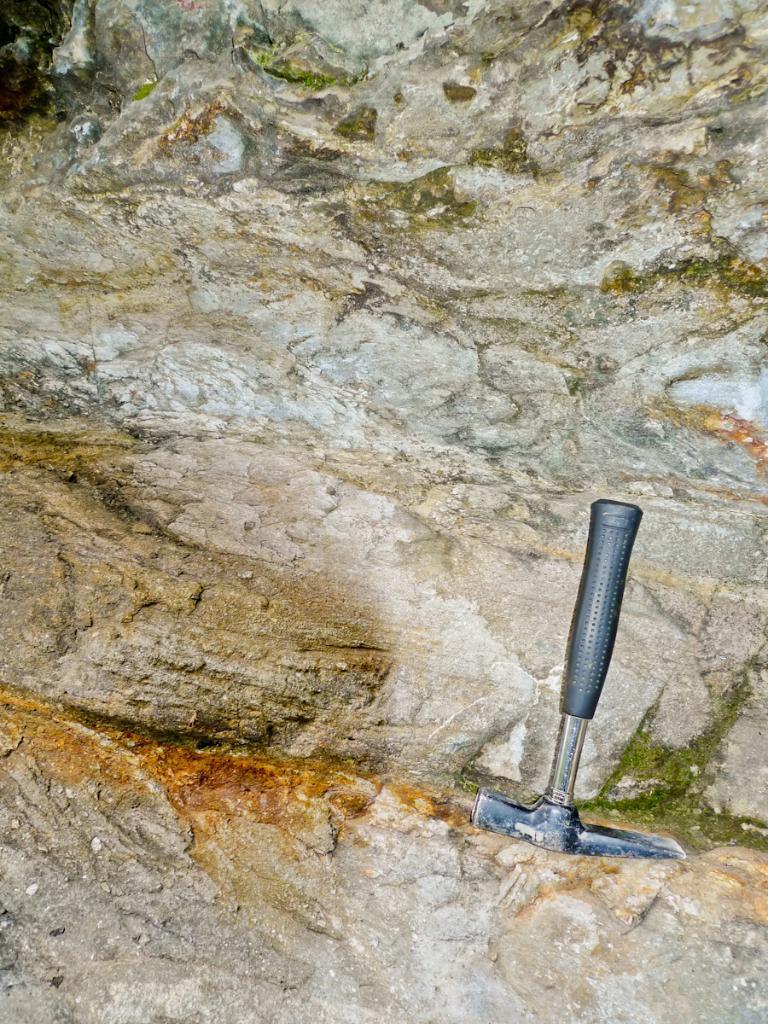Please provide a concise description of this image. In the image we can see the hammer and the rock and on the rock we can see the algae. 